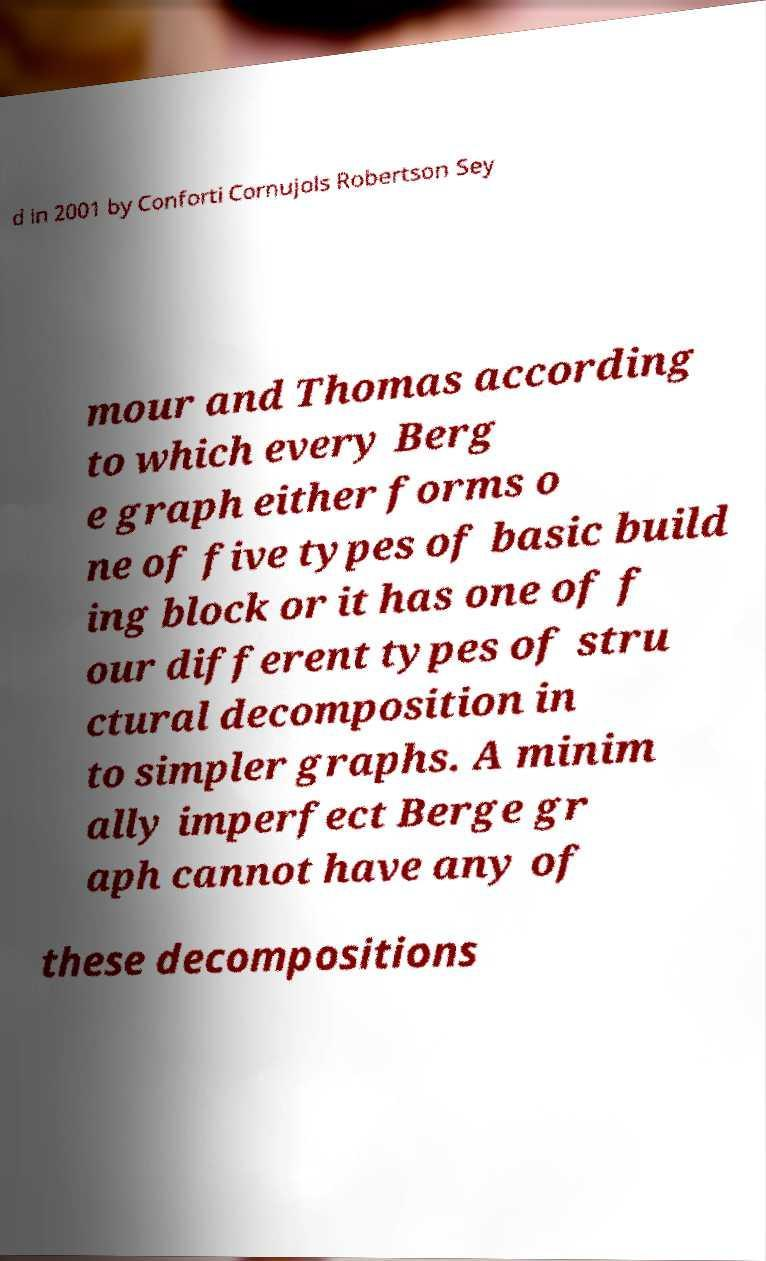For documentation purposes, I need the text within this image transcribed. Could you provide that? d in 2001 by Conforti Cornujols Robertson Sey mour and Thomas according to which every Berg e graph either forms o ne of five types of basic build ing block or it has one of f our different types of stru ctural decomposition in to simpler graphs. A minim ally imperfect Berge gr aph cannot have any of these decompositions 